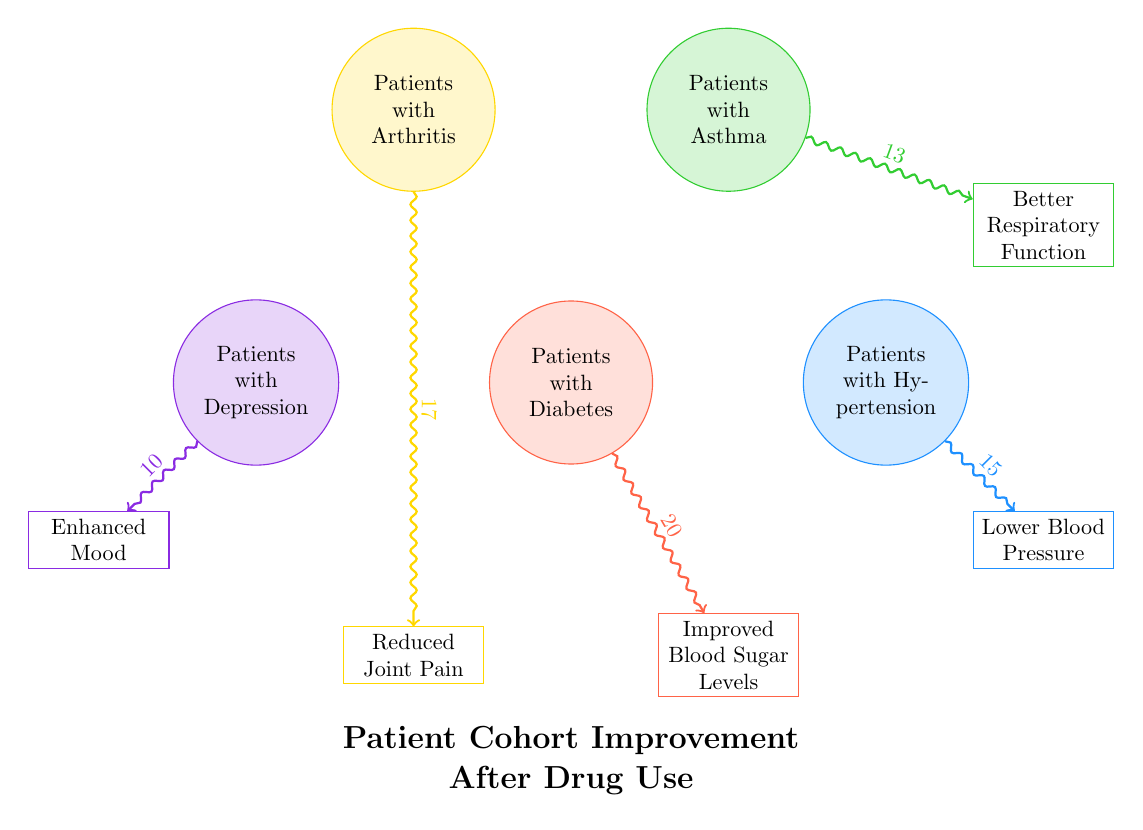What is the value representing improved blood sugar levels from patients with diabetes? The link from "Patients with Diabetes" to "Improved Blood Sugar Levels" shows a value of 20, indicating the level of improvement directly associated with this patient cohort.
Answer: 20 Which patient cohort shows the least improvement after drug use? The connections from all patient cohorts to their respective improvements show the values, with "Patients with Depression" linked to "Enhanced Mood" having the lowest value of 10.
Answer: Patients with Depression What percentage of patients with arthritis reported reduced joint pain? The link from "Patients with Arthritis" to "Reduced Joint Pain" indicates a value of 17, which is the total number of patients experiencing this improvement. To find the percentage, we need the total number of persons involved in the cohort, which isn't given, so we focus solely on the value of improvement.
Answer: 17 How many total patient cohorts are represented in the diagram? By counting all distinct categories listed in the nodes section — Patients with Diabetes, Hypertension, Asthma, Arthritis, and Depression — we find that there are five patient cohorts, each representing a unique health issue.
Answer: 5 Which two improvements correspond to the highest values from their patient cohorts? By examining the links, "Improved Blood Sugar Levels" from "Patients with Diabetes" has the highest value of 20, and "Reduced Joint Pain" from "Patients with Arthritis" follows next with a value of 17. Thus, these two improvements correspond to the highest values.
Answer: Improved Blood Sugar Levels, Reduced Joint Pain What is the color associated with the patients suffering from hypertension? Upon analyzing the diagram, the node labeled "Patients with Hypertension" is drawn using the defined color associated with hypertensionColor, which is RGB values of 30, 144, 255. This visual aspect directly corresponds to its identification.
Answer: Blue Which improvement is directly associated with asthma patients? The diagram shows that "Patients with Asthma" connects to "Better Respiratory Function," indicating which health improvement is specifically linked to this cohort.
Answer: Better Respiratory Function What is the relationship between patients with arthritis and their improvement in drug response? The diagram illustrates a directed link from "Patients with Arthritis" to "Reduced Joint Pain," which indicates that this cohort specifically experiences this improvement after drug use.
Answer: Reduced Joint Pain 